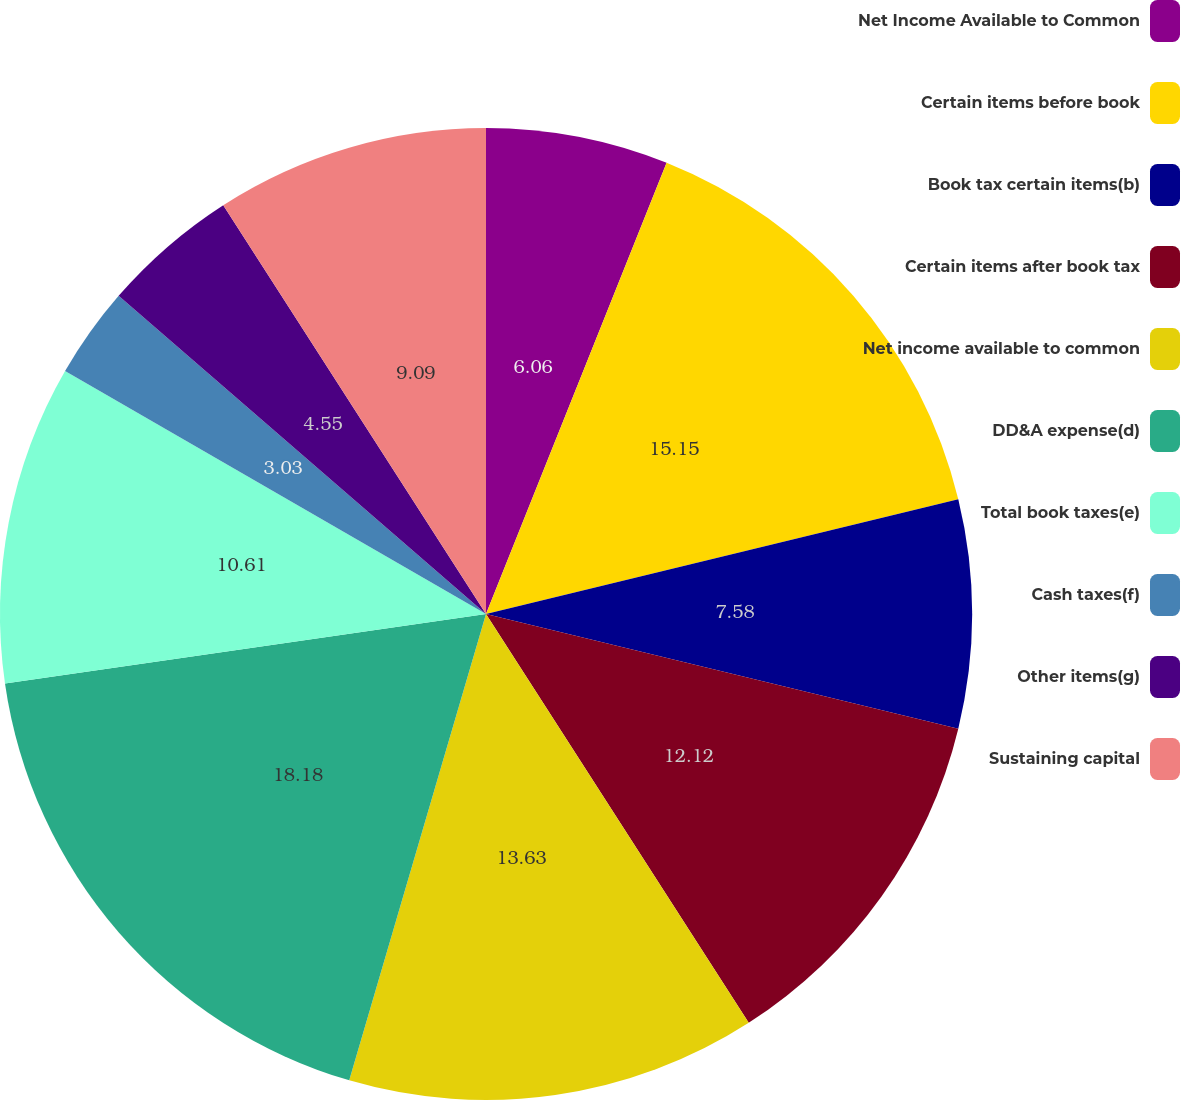<chart> <loc_0><loc_0><loc_500><loc_500><pie_chart><fcel>Net Income Available to Common<fcel>Certain items before book<fcel>Book tax certain items(b)<fcel>Certain items after book tax<fcel>Net income available to common<fcel>DD&A expense(d)<fcel>Total book taxes(e)<fcel>Cash taxes(f)<fcel>Other items(g)<fcel>Sustaining capital<nl><fcel>6.06%<fcel>15.15%<fcel>7.58%<fcel>12.12%<fcel>13.63%<fcel>18.18%<fcel>10.61%<fcel>3.03%<fcel>4.55%<fcel>9.09%<nl></chart> 